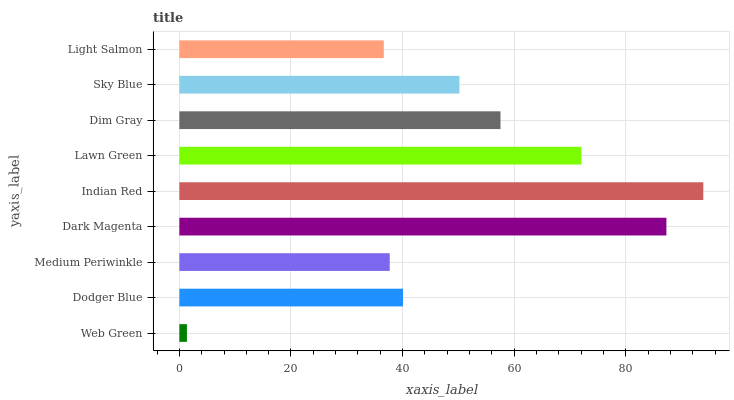Is Web Green the minimum?
Answer yes or no. Yes. Is Indian Red the maximum?
Answer yes or no. Yes. Is Dodger Blue the minimum?
Answer yes or no. No. Is Dodger Blue the maximum?
Answer yes or no. No. Is Dodger Blue greater than Web Green?
Answer yes or no. Yes. Is Web Green less than Dodger Blue?
Answer yes or no. Yes. Is Web Green greater than Dodger Blue?
Answer yes or no. No. Is Dodger Blue less than Web Green?
Answer yes or no. No. Is Sky Blue the high median?
Answer yes or no. Yes. Is Sky Blue the low median?
Answer yes or no. Yes. Is Lawn Green the high median?
Answer yes or no. No. Is Dim Gray the low median?
Answer yes or no. No. 